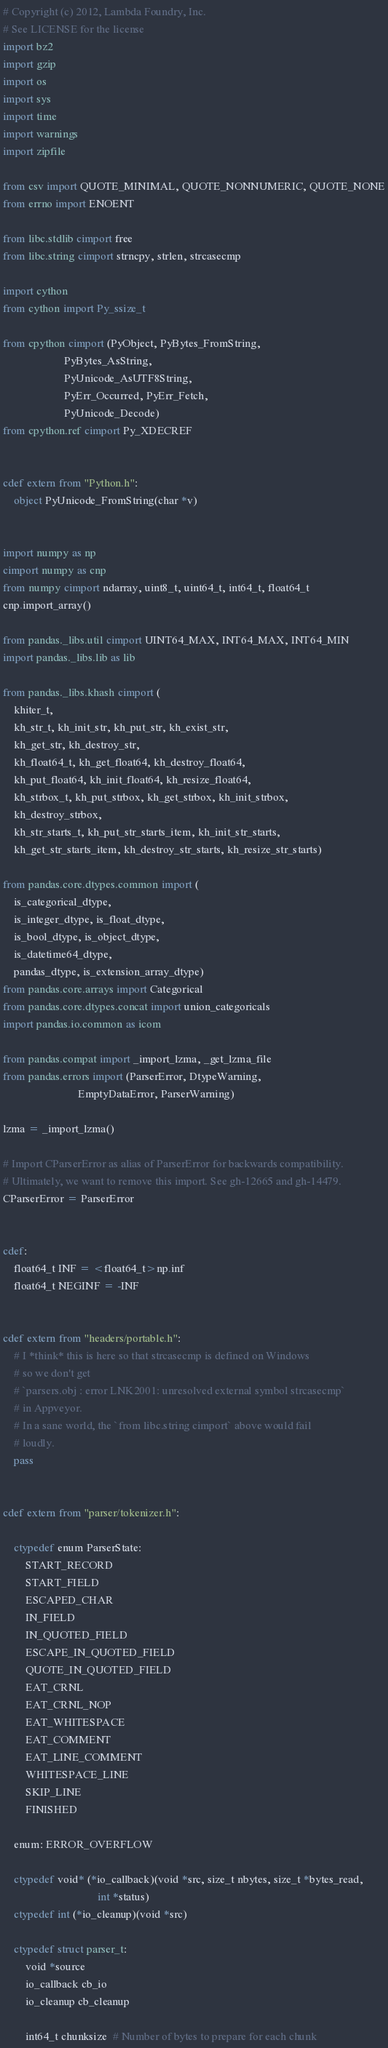Convert code to text. <code><loc_0><loc_0><loc_500><loc_500><_Cython_># Copyright (c) 2012, Lambda Foundry, Inc.
# See LICENSE for the license
import bz2
import gzip
import os
import sys
import time
import warnings
import zipfile

from csv import QUOTE_MINIMAL, QUOTE_NONNUMERIC, QUOTE_NONE
from errno import ENOENT

from libc.stdlib cimport free
from libc.string cimport strncpy, strlen, strcasecmp

import cython
from cython import Py_ssize_t

from cpython cimport (PyObject, PyBytes_FromString,
                      PyBytes_AsString,
                      PyUnicode_AsUTF8String,
                      PyErr_Occurred, PyErr_Fetch,
                      PyUnicode_Decode)
from cpython.ref cimport Py_XDECREF


cdef extern from "Python.h":
    object PyUnicode_FromString(char *v)


import numpy as np
cimport numpy as cnp
from numpy cimport ndarray, uint8_t, uint64_t, int64_t, float64_t
cnp.import_array()

from pandas._libs.util cimport UINT64_MAX, INT64_MAX, INT64_MIN
import pandas._libs.lib as lib

from pandas._libs.khash cimport (
    khiter_t,
    kh_str_t, kh_init_str, kh_put_str, kh_exist_str,
    kh_get_str, kh_destroy_str,
    kh_float64_t, kh_get_float64, kh_destroy_float64,
    kh_put_float64, kh_init_float64, kh_resize_float64,
    kh_strbox_t, kh_put_strbox, kh_get_strbox, kh_init_strbox,
    kh_destroy_strbox,
    kh_str_starts_t, kh_put_str_starts_item, kh_init_str_starts,
    kh_get_str_starts_item, kh_destroy_str_starts, kh_resize_str_starts)

from pandas.core.dtypes.common import (
    is_categorical_dtype,
    is_integer_dtype, is_float_dtype,
    is_bool_dtype, is_object_dtype,
    is_datetime64_dtype,
    pandas_dtype, is_extension_array_dtype)
from pandas.core.arrays import Categorical
from pandas.core.dtypes.concat import union_categoricals
import pandas.io.common as icom

from pandas.compat import _import_lzma, _get_lzma_file
from pandas.errors import (ParserError, DtypeWarning,
                           EmptyDataError, ParserWarning)

lzma = _import_lzma()

# Import CParserError as alias of ParserError for backwards compatibility.
# Ultimately, we want to remove this import. See gh-12665 and gh-14479.
CParserError = ParserError


cdef:
    float64_t INF = <float64_t>np.inf
    float64_t NEGINF = -INF


cdef extern from "headers/portable.h":
    # I *think* this is here so that strcasecmp is defined on Windows
    # so we don't get
    # `parsers.obj : error LNK2001: unresolved external symbol strcasecmp`
    # in Appveyor.
    # In a sane world, the `from libc.string cimport` above would fail
    # loudly.
    pass


cdef extern from "parser/tokenizer.h":

    ctypedef enum ParserState:
        START_RECORD
        START_FIELD
        ESCAPED_CHAR
        IN_FIELD
        IN_QUOTED_FIELD
        ESCAPE_IN_QUOTED_FIELD
        QUOTE_IN_QUOTED_FIELD
        EAT_CRNL
        EAT_CRNL_NOP
        EAT_WHITESPACE
        EAT_COMMENT
        EAT_LINE_COMMENT
        WHITESPACE_LINE
        SKIP_LINE
        FINISHED

    enum: ERROR_OVERFLOW

    ctypedef void* (*io_callback)(void *src, size_t nbytes, size_t *bytes_read,
                                  int *status)
    ctypedef int (*io_cleanup)(void *src)

    ctypedef struct parser_t:
        void *source
        io_callback cb_io
        io_cleanup cb_cleanup

        int64_t chunksize  # Number of bytes to prepare for each chunk</code> 